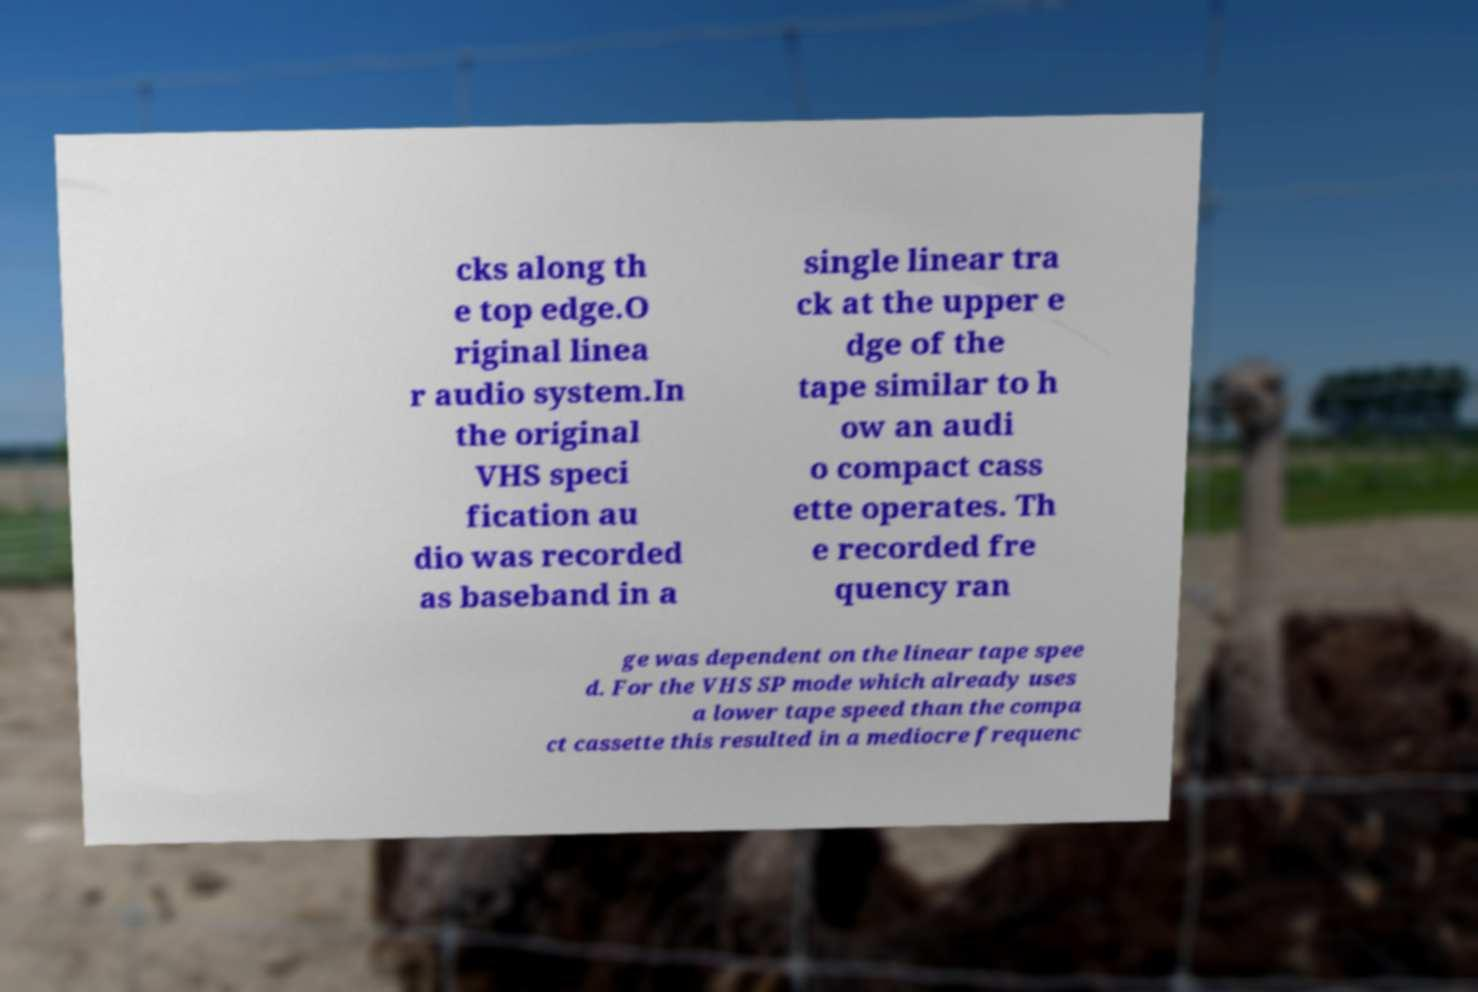Can you read and provide the text displayed in the image?This photo seems to have some interesting text. Can you extract and type it out for me? cks along th e top edge.O riginal linea r audio system.In the original VHS speci fication au dio was recorded as baseband in a single linear tra ck at the upper e dge of the tape similar to h ow an audi o compact cass ette operates. Th e recorded fre quency ran ge was dependent on the linear tape spee d. For the VHS SP mode which already uses a lower tape speed than the compa ct cassette this resulted in a mediocre frequenc 